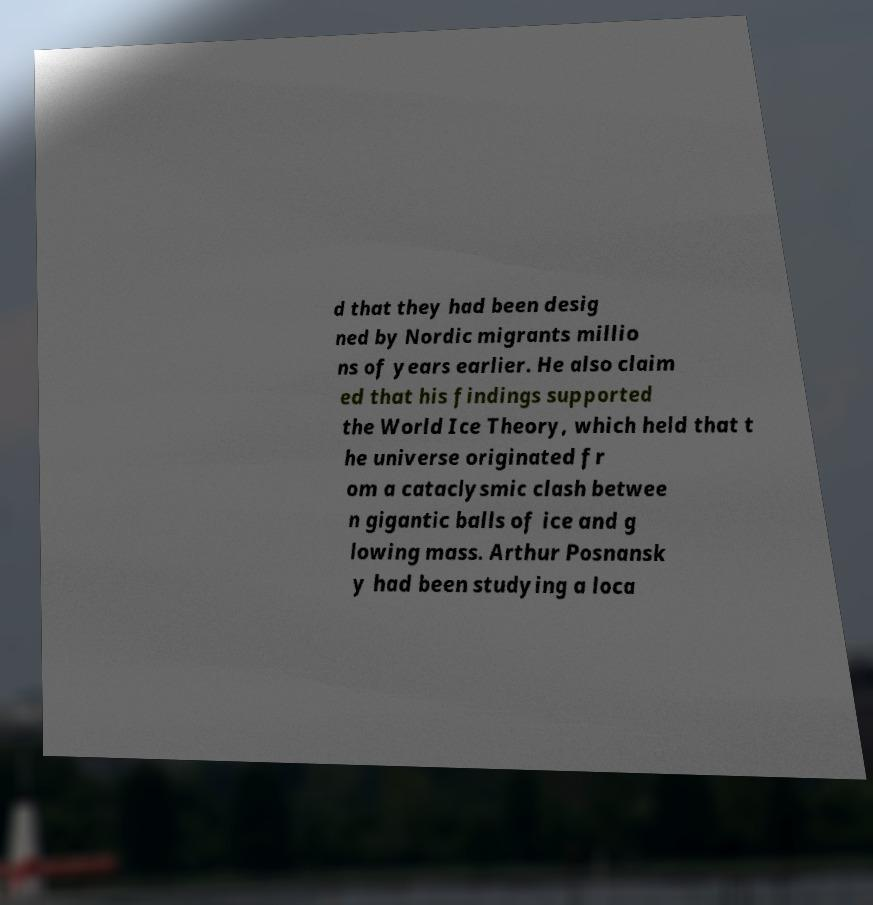Please identify and transcribe the text found in this image. d that they had been desig ned by Nordic migrants millio ns of years earlier. He also claim ed that his findings supported the World Ice Theory, which held that t he universe originated fr om a cataclysmic clash betwee n gigantic balls of ice and g lowing mass. Arthur Posnansk y had been studying a loca 